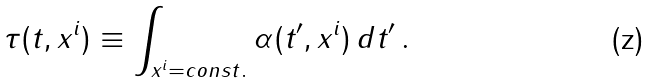<formula> <loc_0><loc_0><loc_500><loc_500>\tau ( t , x ^ { i } ) \equiv \int _ { x ^ { i } = c o n s t . } \alpha ( t ^ { \prime } , x ^ { i } ) \, d t ^ { \prime } \, .</formula> 